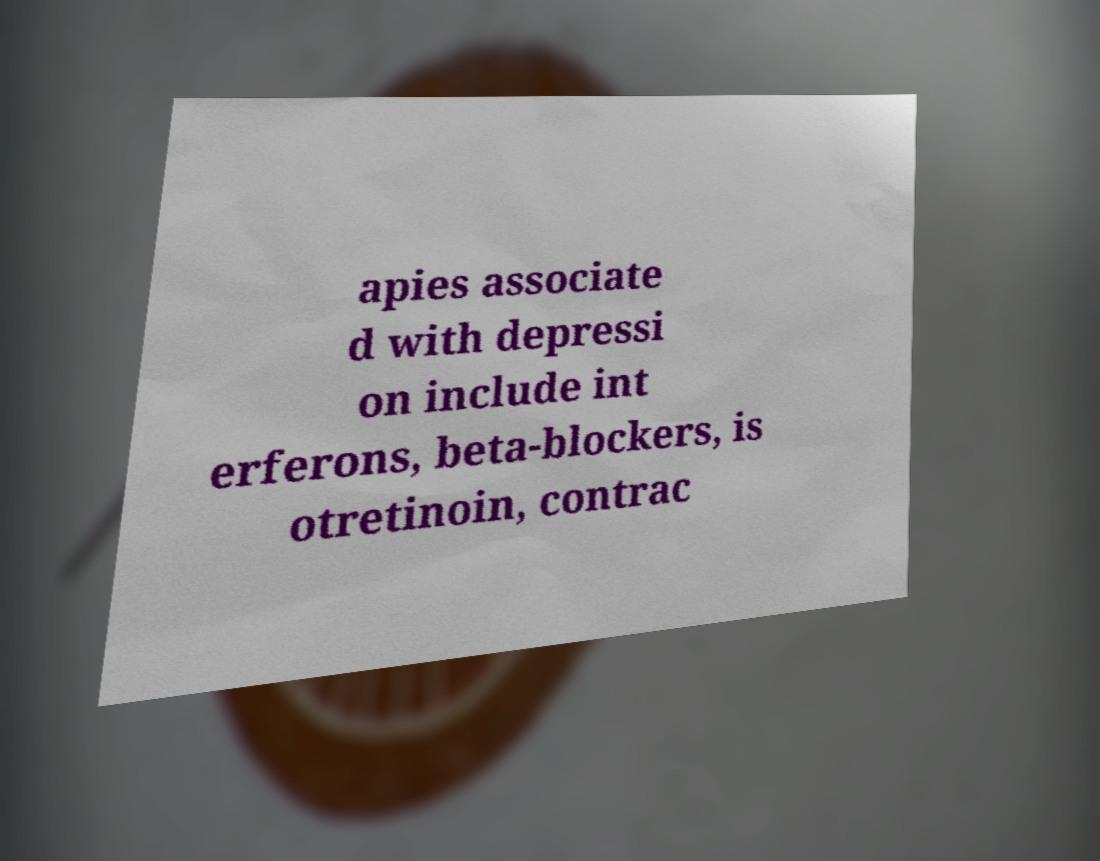What messages or text are displayed in this image? I need them in a readable, typed format. apies associate d with depressi on include int erferons, beta-blockers, is otretinoin, contrac 